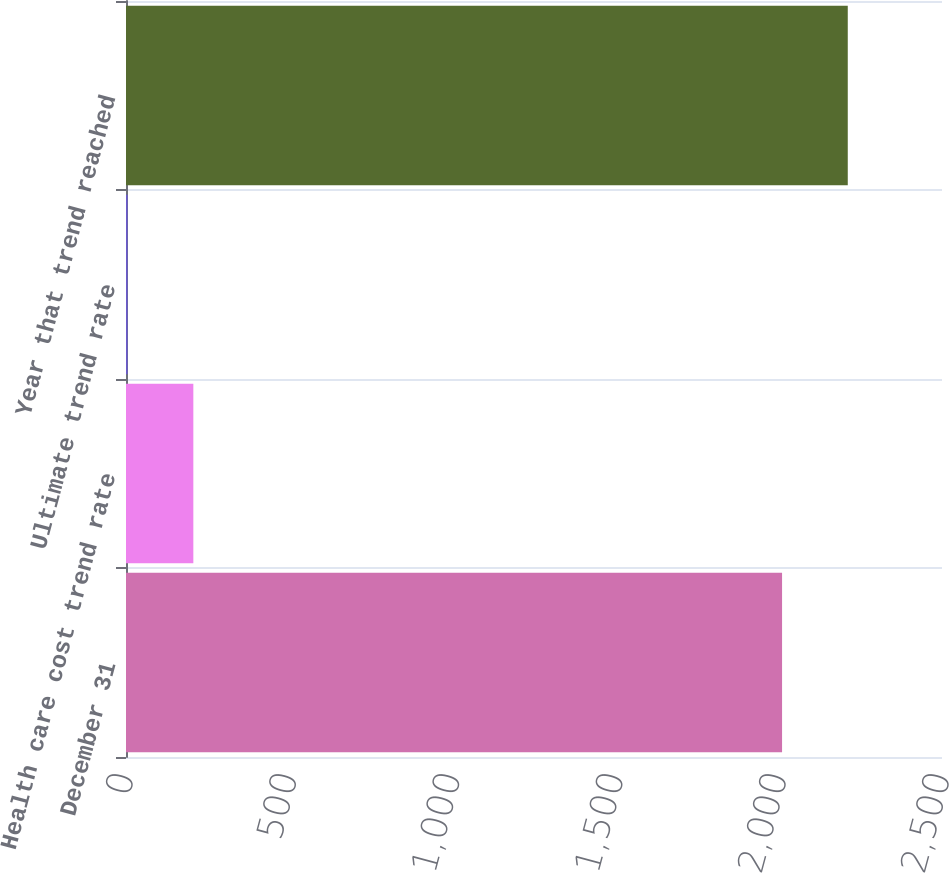Convert chart. <chart><loc_0><loc_0><loc_500><loc_500><bar_chart><fcel>December 31<fcel>Health care cost trend rate<fcel>Ultimate trend rate<fcel>Year that trend reached<nl><fcel>2010<fcel>206.3<fcel>5<fcel>2211.3<nl></chart> 